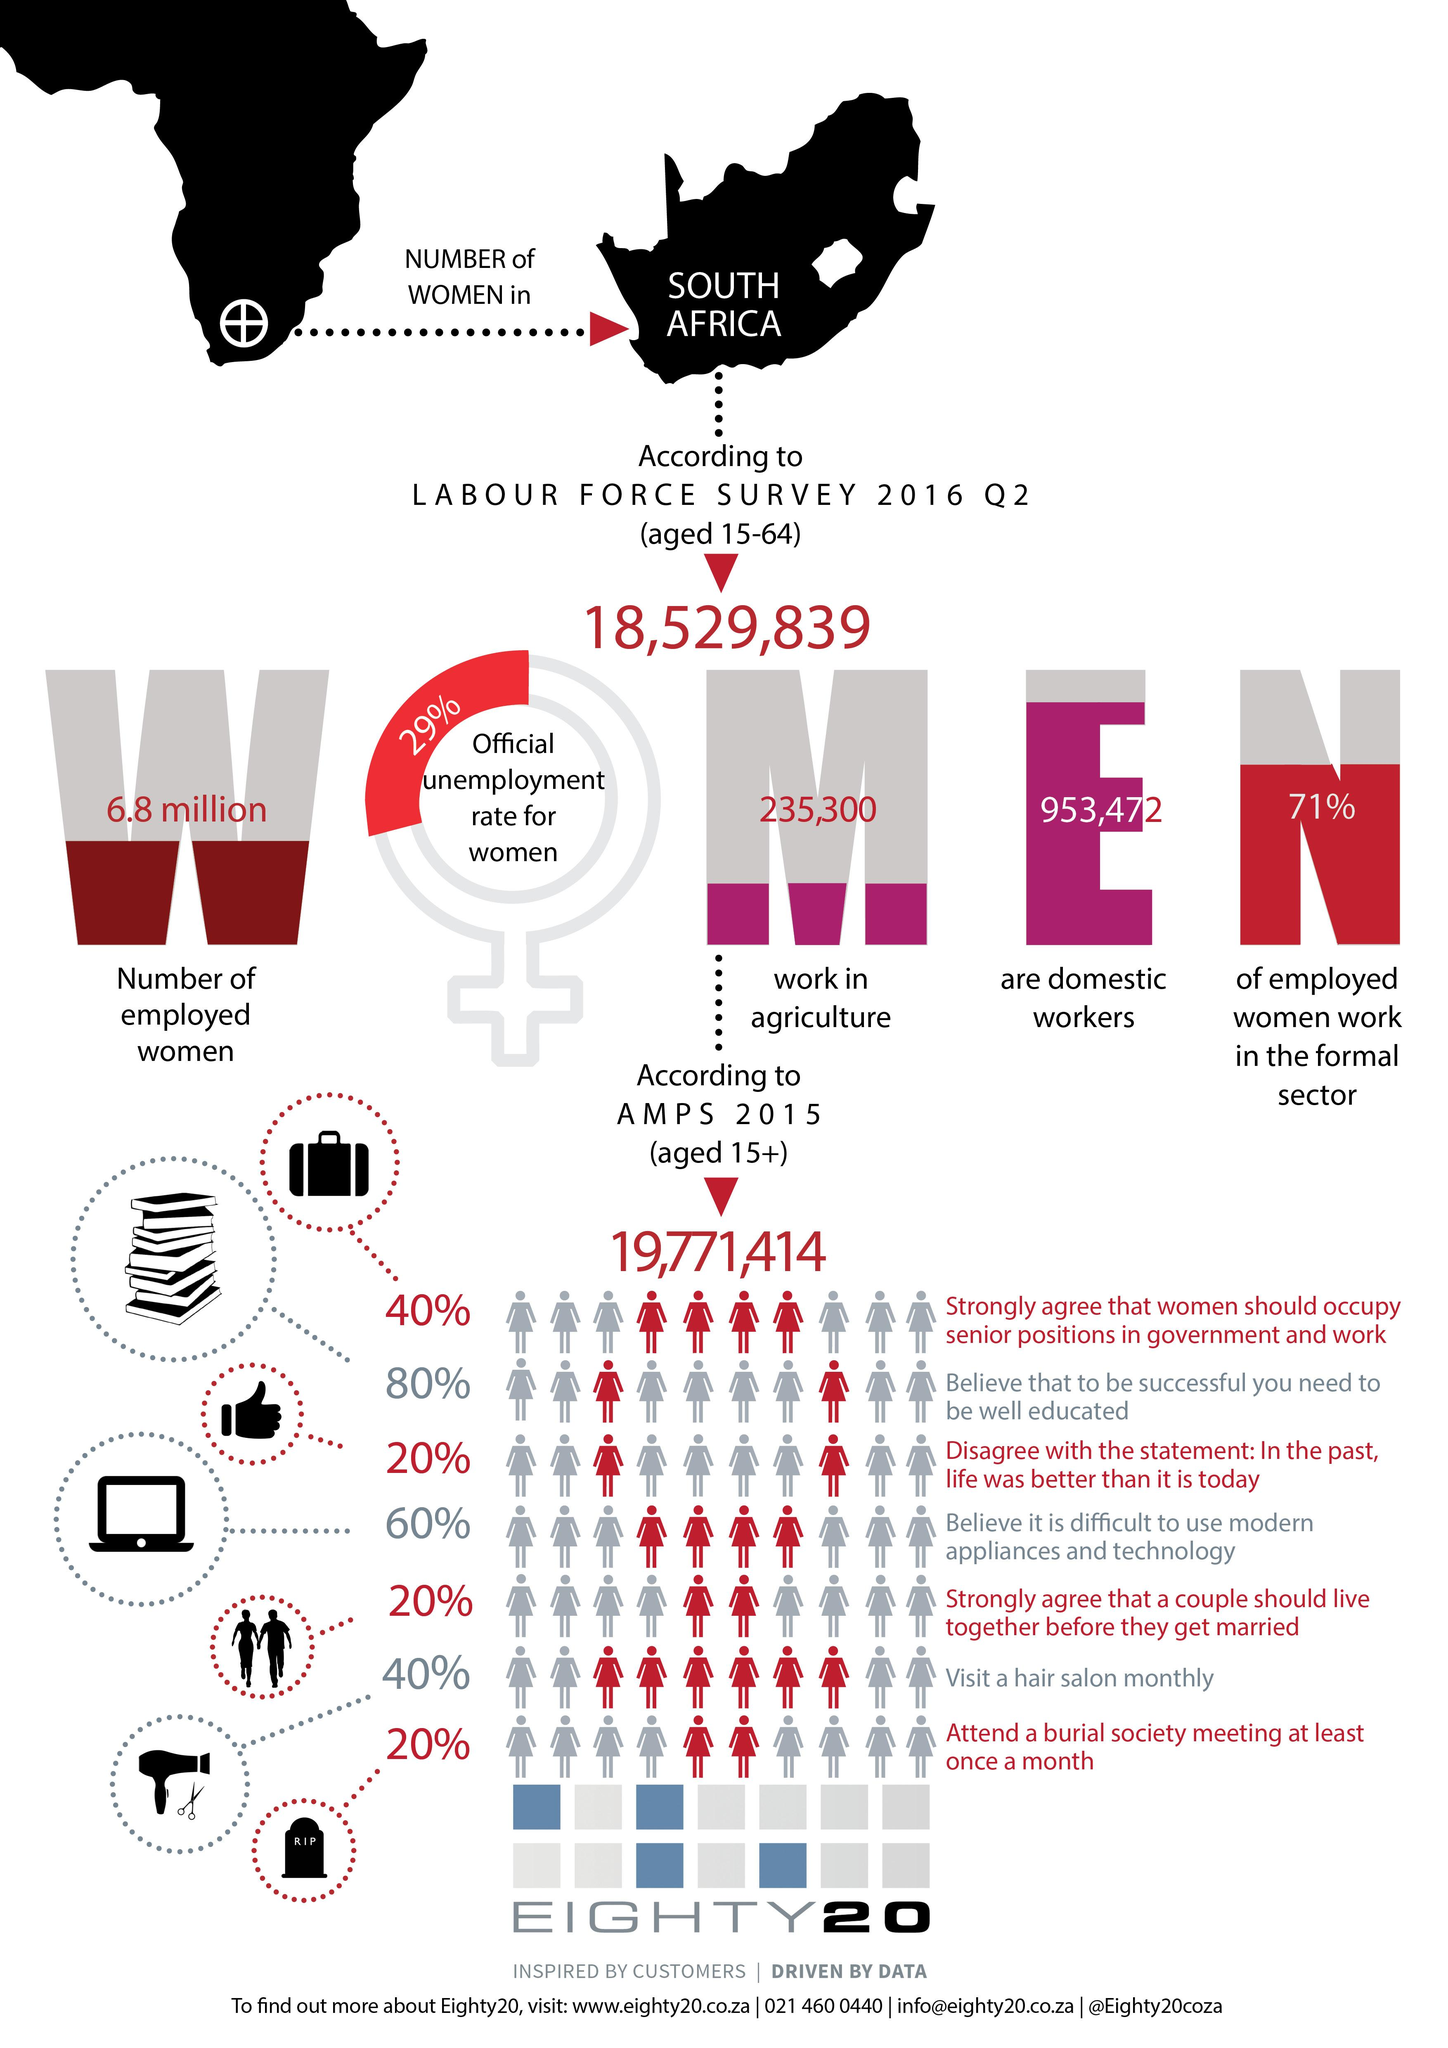Highlight a few significant elements in this photo. According to the Labour force survey conducted in the second quarter of 2016, there were approximately 235,300 women aged 15-64 working in the agricultural sector of South Africa. The official unemployment rate for women in South Africa, as reported in the Labour Force survey for the second quarter of 2016, was 29%. According to the Labour force survey for Q2 2016, a total of 953,472 South African women aged 15-64 were identified as domestic workers. According to the Labour Force Survey for Q2 2016 in South Africa, there were approximately 6.8 million employed women aged 15-64 in the country. 